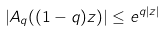<formula> <loc_0><loc_0><loc_500><loc_500>\left | A _ { q } ( ( 1 - q ) z ) \right | \leq e ^ { q | z | }</formula> 